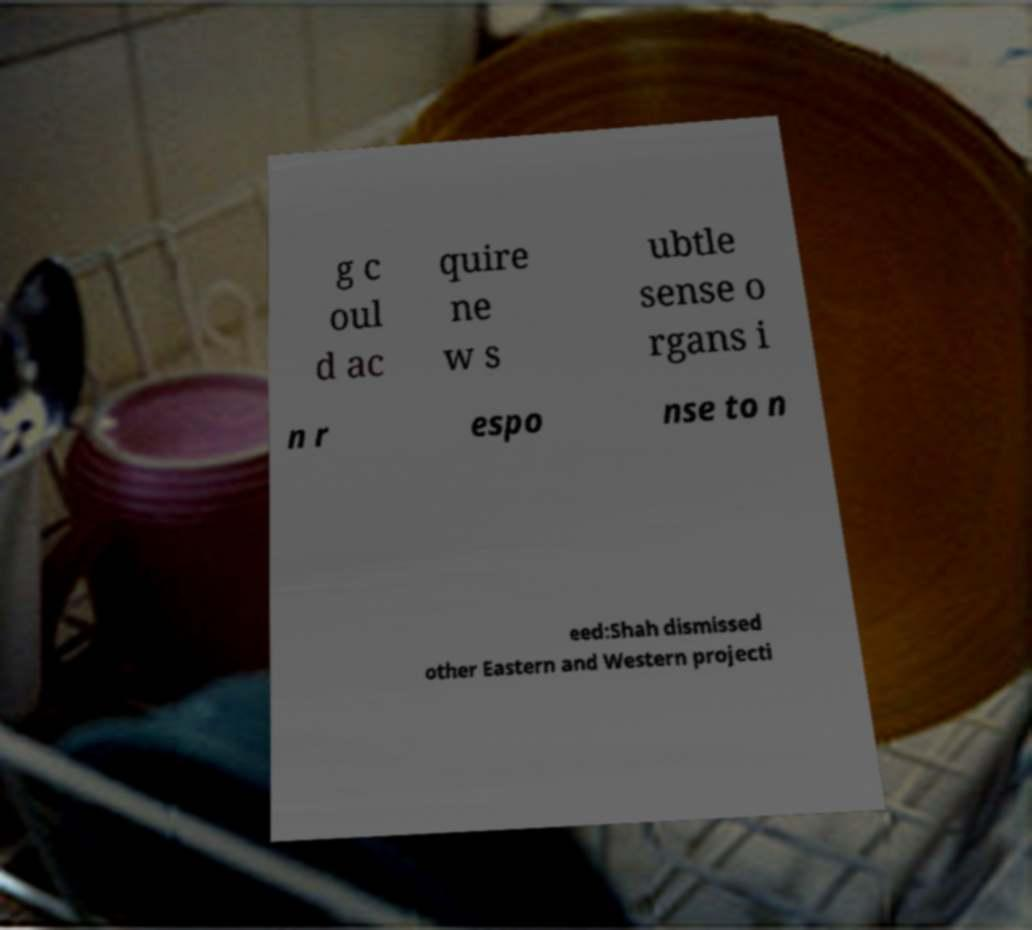There's text embedded in this image that I need extracted. Can you transcribe it verbatim? g c oul d ac quire ne w s ubtle sense o rgans i n r espo nse to n eed:Shah dismissed other Eastern and Western projecti 